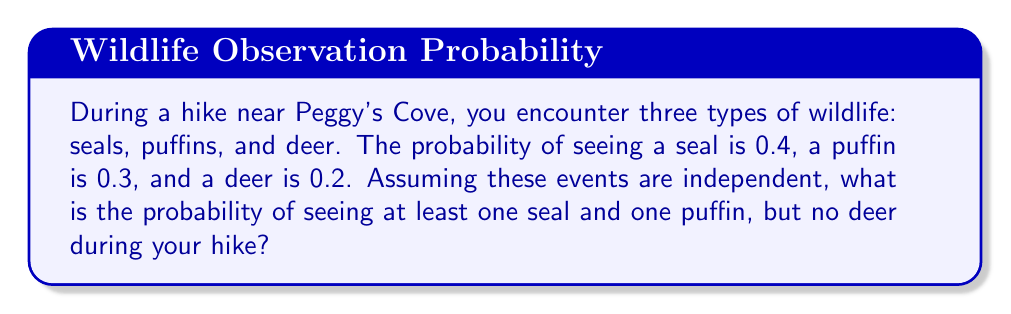Solve this math problem. Let's approach this step-by-step:

1) First, let's define our events:
   S: seeing a seal
   P: seeing a puffin
   D: seeing a deer

2) We're given the following probabilities:
   P(S) = 0.4
   P(P) = 0.3
   P(D) = 0.2

3) We want to find the probability of seeing at least one seal AND at least one puffin AND no deer. In probability notation, this is:

   P((S ∩ P) ∩ D')

   Where D' represents the complement of D (not seeing a deer).

4) Since these events are independent, we can multiply their probabilities:

   P((S ∩ P) ∩ D') = P(S) × P(P) × P(D')

5) We know P(S) and P(P), but we need to calculate P(D'):

   P(D') = 1 - P(D) = 1 - 0.2 = 0.8

6) Now we can calculate:

   P((S ∩ P) ∩ D') = 0.4 × 0.3 × 0.8

7) Let's compute this:

   $$0.4 × 0.3 × 0.8 = 0.096$$

Therefore, the probability of seeing at least one seal and one puffin, but no deer during your hike near Peggy's Cove is 0.096 or 9.6%.
Answer: 0.096 or 9.6% 